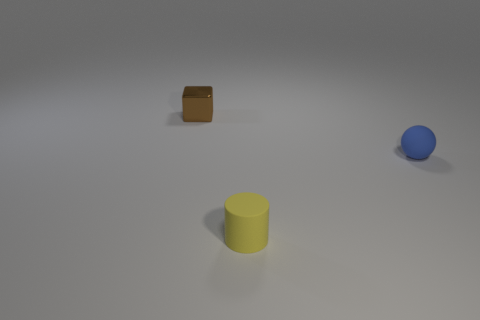Can you hypothesize what the space outside this frame might look like? Based on the minimalist and neutral background within the frame, the space outside it might continue this simplicity, potentially being a larger empty room with consistent lighting. Such a setting could be a studio or a controlled environment meant for photographing objects without interference from background elements. 